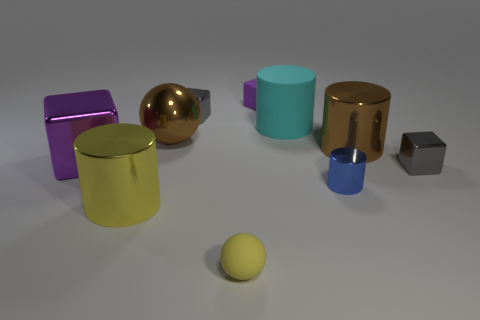Subtract all cyan cylinders. How many gray blocks are left? 2 Subtract all tiny blocks. How many blocks are left? 1 Subtract 1 cubes. How many cubes are left? 3 Subtract all blue cubes. Subtract all brown cylinders. How many cubes are left? 4 Subtract all small purple matte things. Subtract all tiny metal things. How many objects are left? 6 Add 2 small matte objects. How many small matte objects are left? 4 Add 3 green matte spheres. How many green matte spheres exist? 3 Subtract 0 cyan blocks. How many objects are left? 10 Subtract all cylinders. How many objects are left? 6 